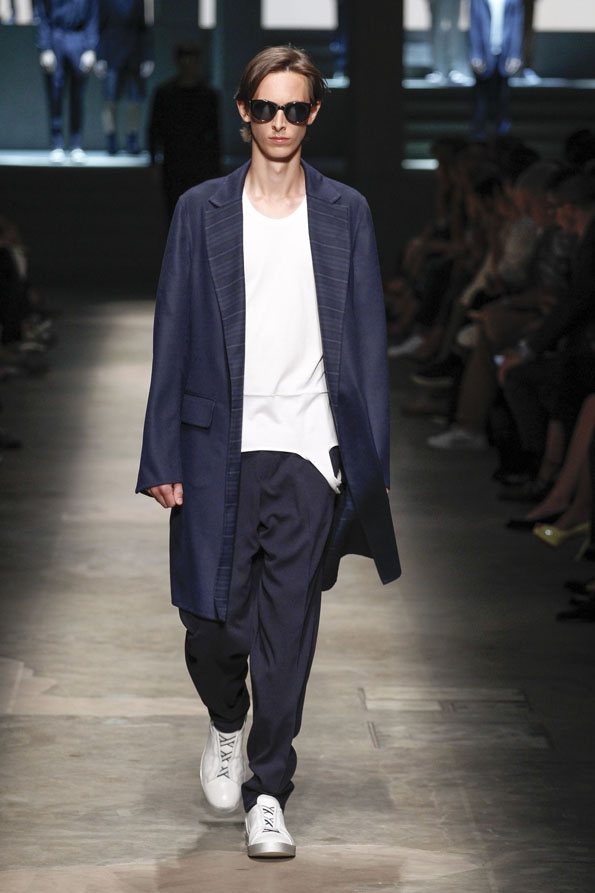How might the setting of the runway contribute to the overall presentation of the outfit? The setting of the runway, with its dim lighting and minimalist design, contributes significantly to the overall presentation of the outfit. The subtle and subdued ambiance accentuates the sophisticated yet relaxed nature of the clothing, allowing the attire to stand out without distractions. The dark, uncluttered backdrop keeps the focus on the model and the fashion, highlighting the tailored cuts and the fluid movement of the fabric as the model walks. This setting complements the theme of modern versatility and understated elegance, emphasizing how the outfit can seamlessly fit into various sophisticated yet casual environments. 